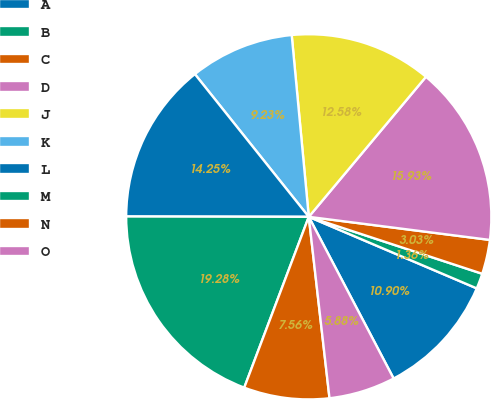Convert chart. <chart><loc_0><loc_0><loc_500><loc_500><pie_chart><fcel>A<fcel>B<fcel>C<fcel>D<fcel>J<fcel>K<fcel>L<fcel>M<fcel>N<fcel>O<nl><fcel>10.9%<fcel>1.36%<fcel>3.03%<fcel>15.93%<fcel>12.58%<fcel>9.23%<fcel>14.25%<fcel>19.28%<fcel>7.56%<fcel>5.88%<nl></chart> 